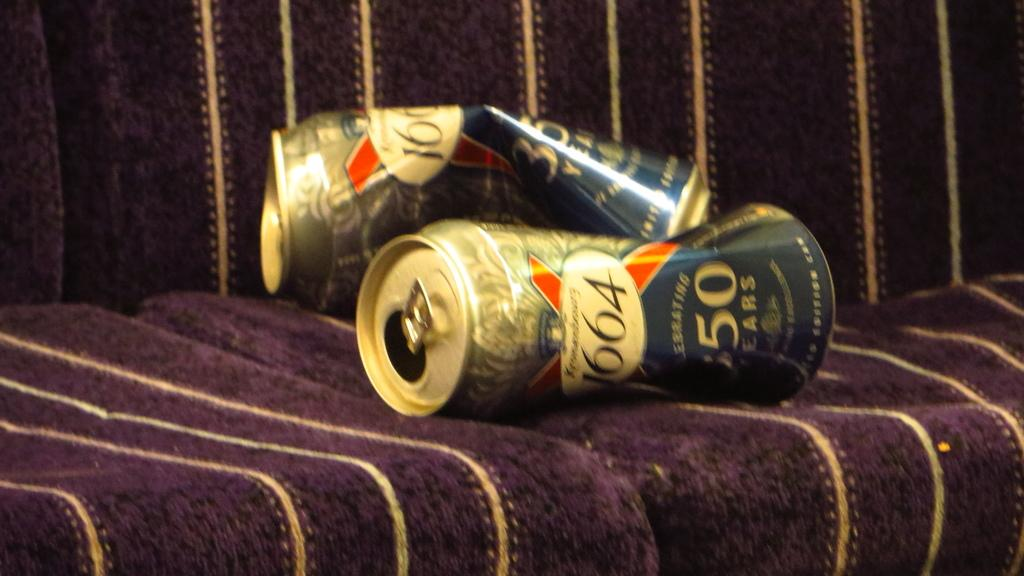Provide a one-sentence caption for the provided image. Slightly crushed cans branded 1664 laid on seating. 